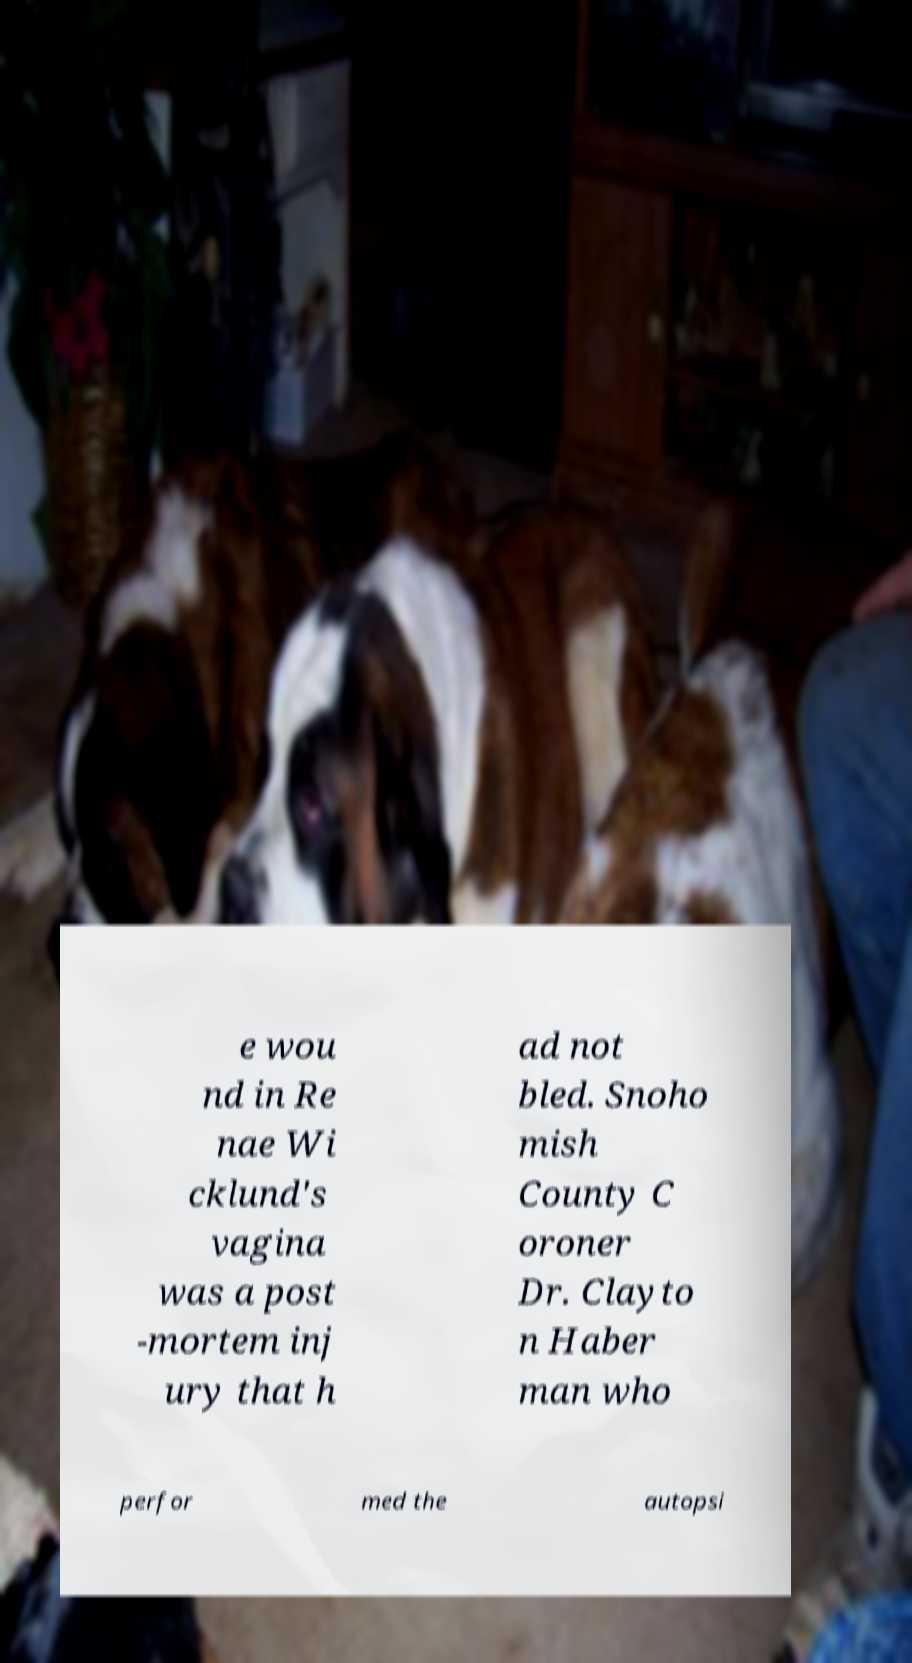What messages or text are displayed in this image? I need them in a readable, typed format. e wou nd in Re nae Wi cklund's vagina was a post -mortem inj ury that h ad not bled. Snoho mish County C oroner Dr. Clayto n Haber man who perfor med the autopsi 